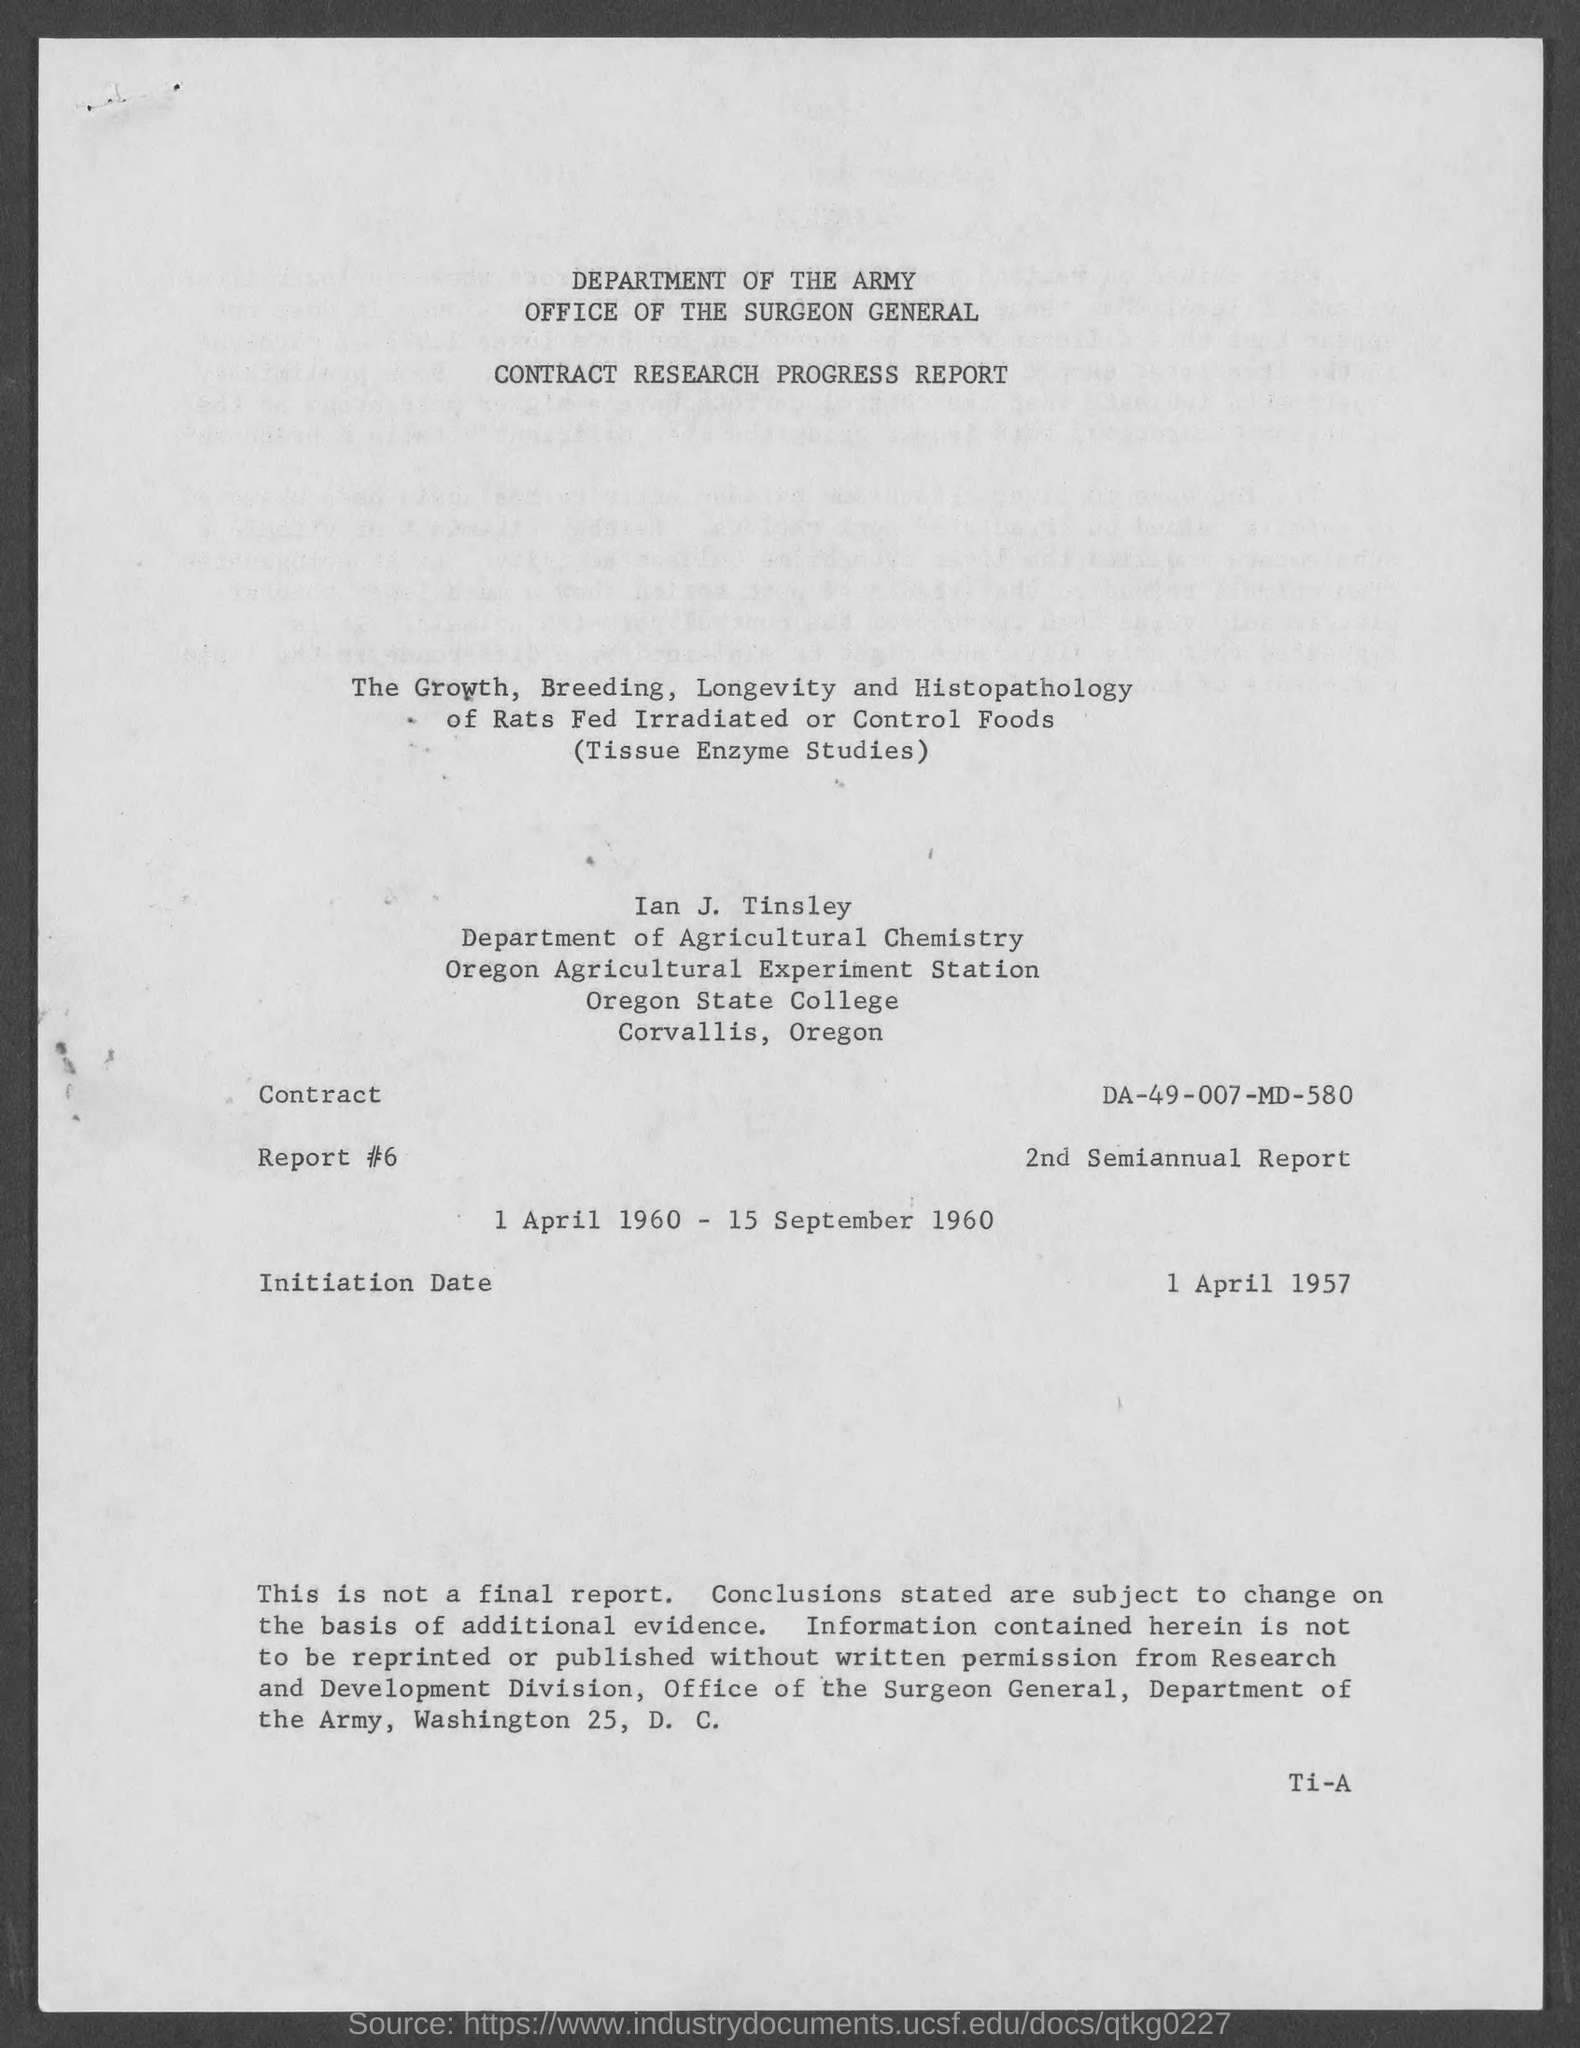Indicate a few pertinent items in this graphic. The initiation date mentioned in the document is 1 April 1957. The Contract No. given in the document is DA-49-007-MD-580. 